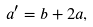<formula> <loc_0><loc_0><loc_500><loc_500>a ^ { \prime } = b + 2 a ,</formula> 